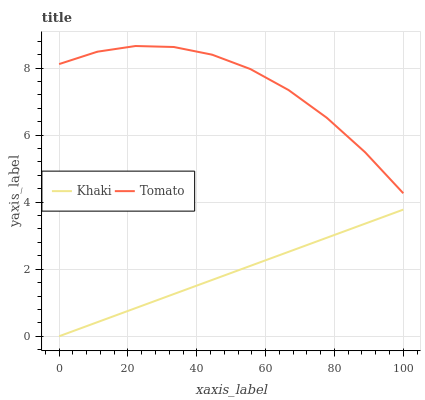Does Khaki have the minimum area under the curve?
Answer yes or no. Yes. Does Tomato have the maximum area under the curve?
Answer yes or no. Yes. Does Khaki have the maximum area under the curve?
Answer yes or no. No. Is Khaki the smoothest?
Answer yes or no. Yes. Is Tomato the roughest?
Answer yes or no. Yes. Is Khaki the roughest?
Answer yes or no. No. Does Khaki have the lowest value?
Answer yes or no. Yes. Does Tomato have the highest value?
Answer yes or no. Yes. Does Khaki have the highest value?
Answer yes or no. No. Is Khaki less than Tomato?
Answer yes or no. Yes. Is Tomato greater than Khaki?
Answer yes or no. Yes. Does Khaki intersect Tomato?
Answer yes or no. No. 